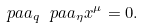Convert formula to latex. <formula><loc_0><loc_0><loc_500><loc_500>\ p a a _ { q } \ p a a _ { \eta } x ^ { \mu } = 0 .</formula> 